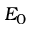<formula> <loc_0><loc_0><loc_500><loc_500>E _ { 0 }</formula> 